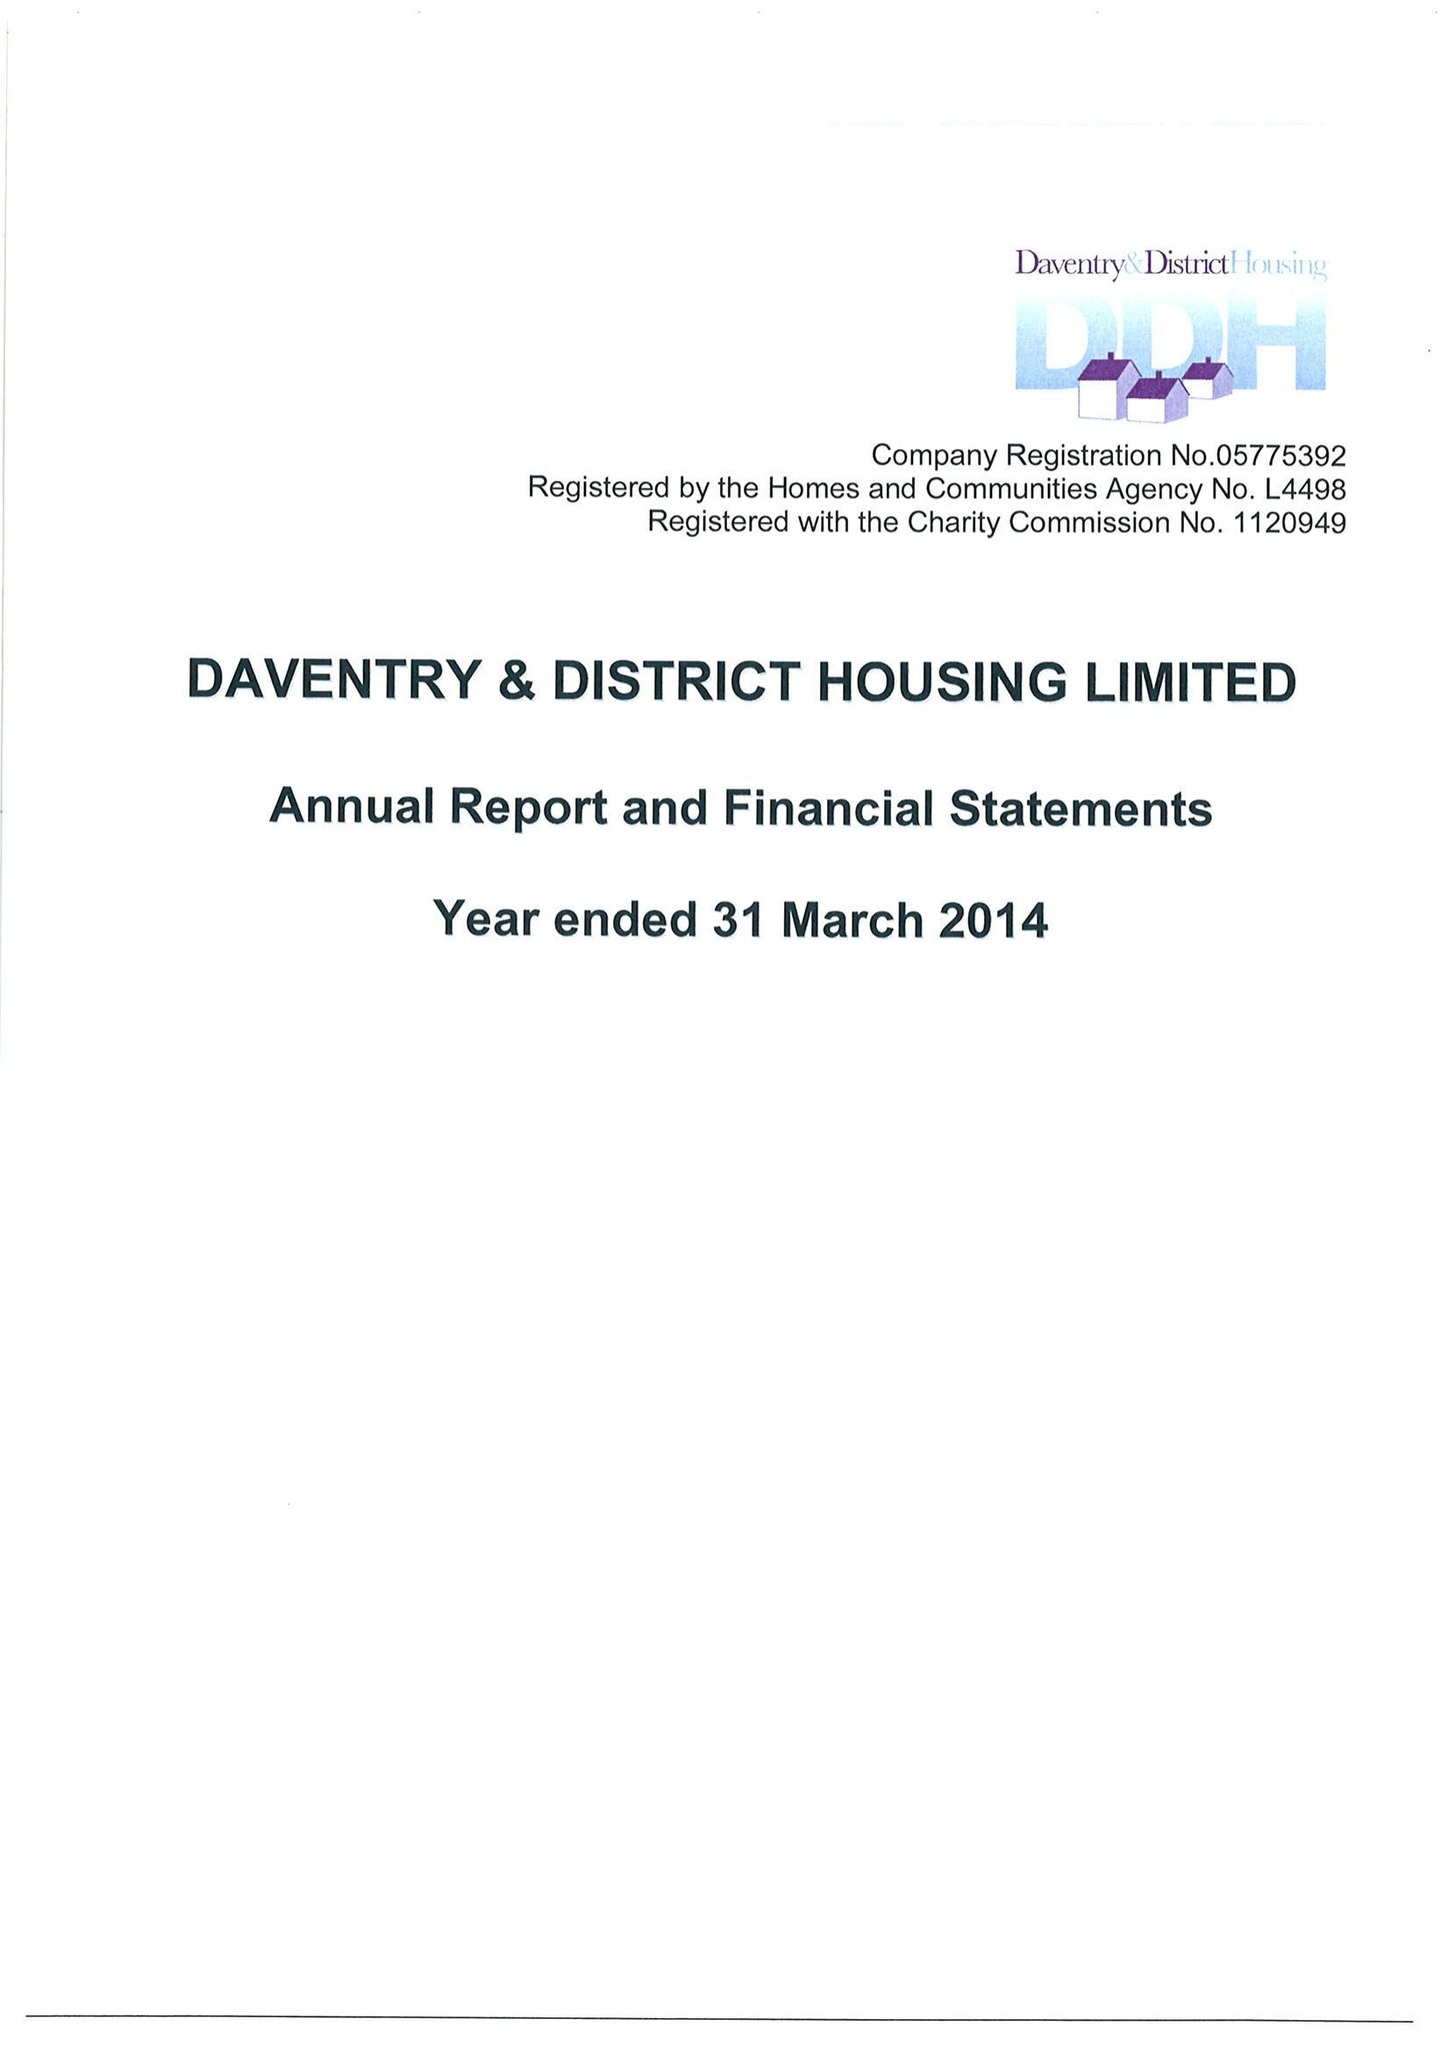What is the value for the address__postcode?
Answer the question using a single word or phrase. DE5 3SW 